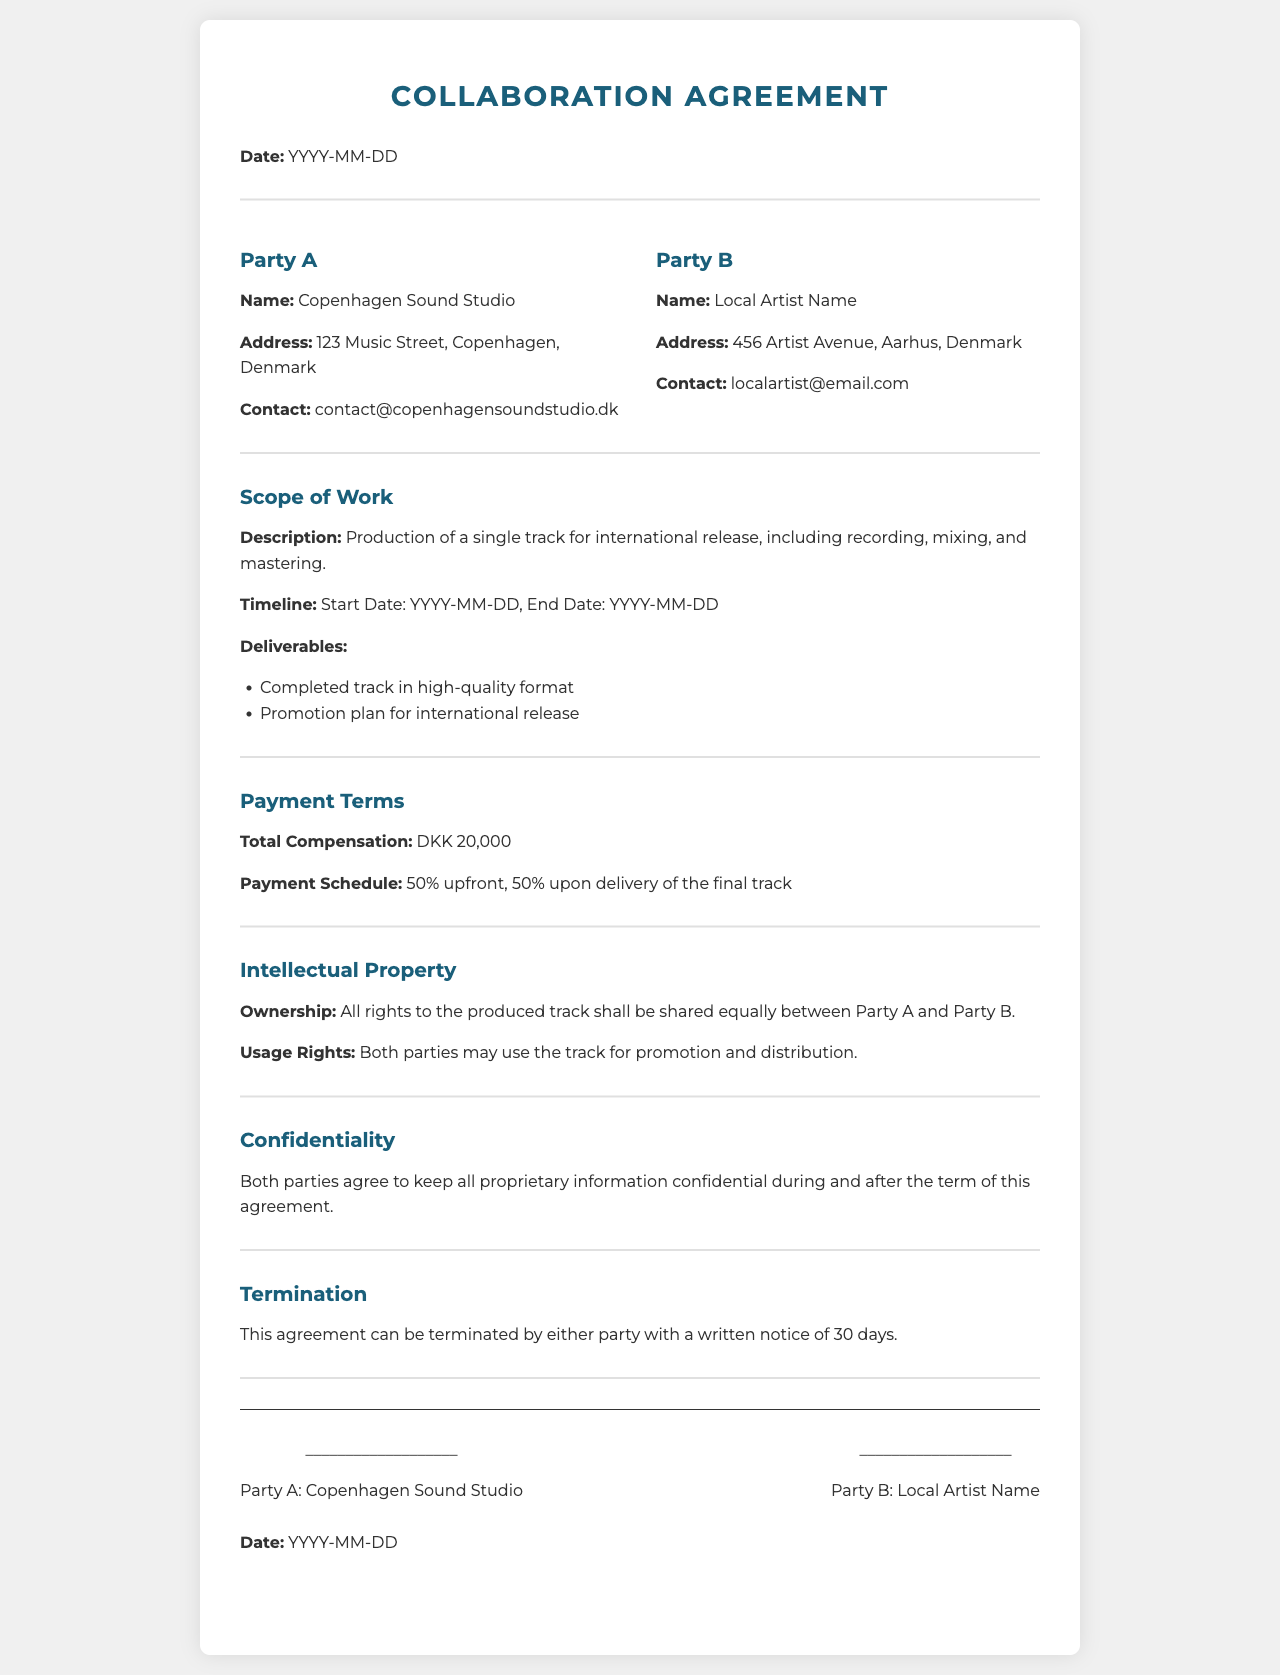What is the name of Party A? The name of Party A is specified in the document as the entity initiating the collaboration, which is Copenhagen Sound Studio.
Answer: Copenhagen Sound Studio What is the total compensation specified in the agreement? The total compensation is detailed in the payment terms section of the document.
Answer: DKK 20,000 What is the start date of the project? The start date is mentioned in the scope of work section, but it is marked as a placeholder.
Answer: YYYY-MM-DD How long is the notice period required for termination of the agreement? The document specifies a required notice period in the termination section.
Answer: 30 days Who holds ownership of the produced track? The ownership of the produced track is stated in the intellectual property section of the document.
Answer: Shared equally What percentage of payment is required upfront? The payment schedule indicates the percentage needed upfront, which is outlined in the payment terms section.
Answer: 50% What is included in the deliverables? The deliverables are listed in the scope of work section, detailing what Party B will provide upon completion.
Answer: Completed track in high-quality format, Promotion plan for international release What is the email address for Party B? Party B's contact information is provided in the parties section of the document.
Answer: localartist@email.com What is stated about confidentiality in the agreement? The confidentiality section outlines the agreement of both parties regarding proprietary information.
Answer: Keep all proprietary information confidential 